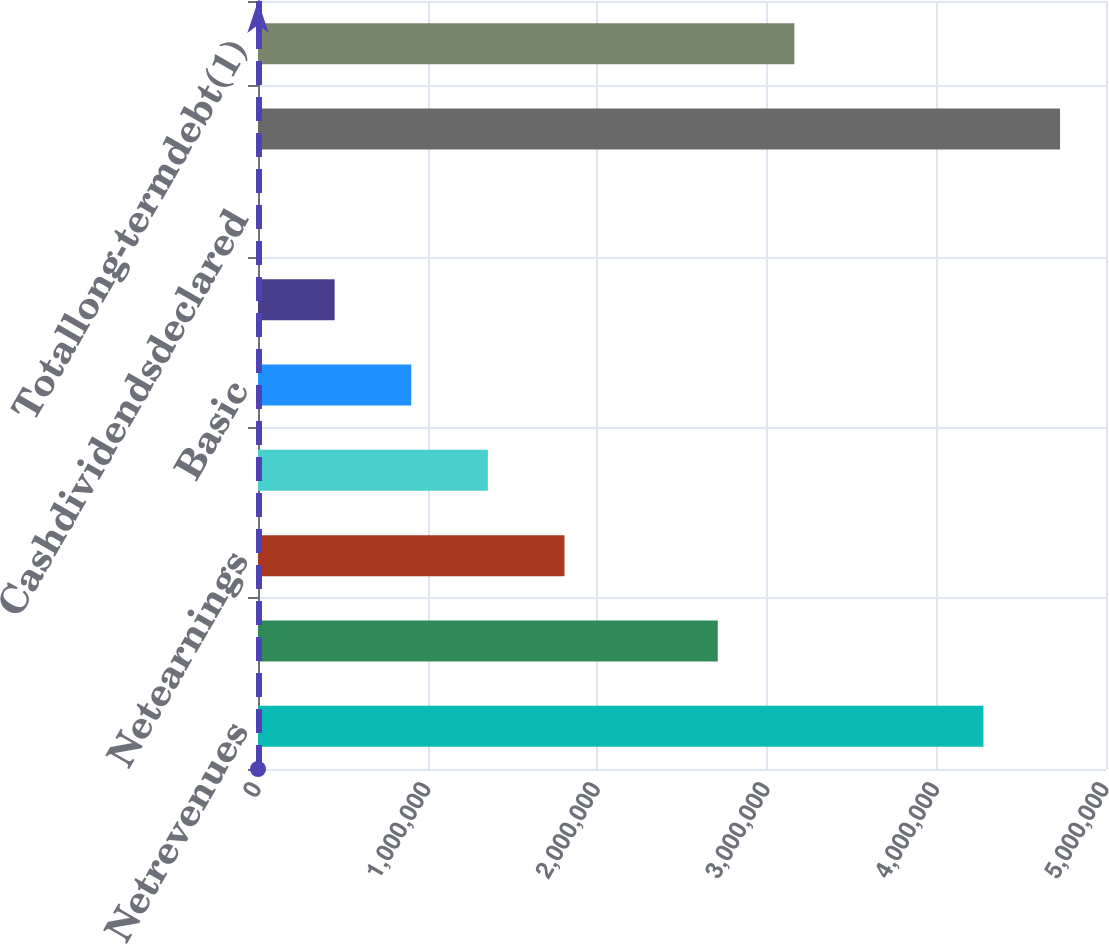<chart> <loc_0><loc_0><loc_500><loc_500><bar_chart><fcel>Netrevenues<fcel>OperatingProfit<fcel>Netearnings<fcel>Unnamed: 3<fcel>Basic<fcel>Diluted<fcel>Cashdividendsdeclared<fcel>Totalassets<fcel>Totallong-termdebt(1)<nl><fcel>4.27721e+06<fcel>2.71086e+06<fcel>1.80724e+06<fcel>1.35543e+06<fcel>903621<fcel>451812<fcel>1.72<fcel>4.72902e+06<fcel>3.16267e+06<nl></chart> 